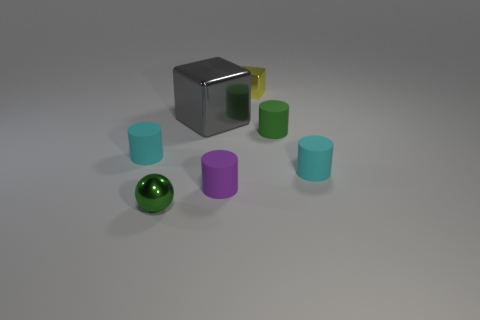Is there any other thing that has the same color as the metallic ball?
Your answer should be very brief. Yes. Is the number of cyan matte objects right of the tiny green cylinder the same as the number of purple rubber objects that are behind the small purple thing?
Offer a terse response. No. Is the material of the gray cube the same as the tiny yellow cube?
Offer a very short reply. Yes. How many green objects are small matte things or big objects?
Your answer should be very brief. 1. What number of purple rubber objects have the same shape as the tiny yellow shiny object?
Offer a terse response. 0. What is the tiny purple thing made of?
Keep it short and to the point. Rubber. Is the number of cyan matte things that are in front of the green metallic thing the same as the number of large yellow cylinders?
Your answer should be very brief. Yes. What shape is the yellow shiny object that is the same size as the purple matte object?
Your answer should be very brief. Cube. Is there a cyan rubber cylinder to the left of the cyan thing that is right of the small yellow shiny cube?
Keep it short and to the point. Yes. How many small objects are either red things or cyan matte cylinders?
Give a very brief answer. 2. 